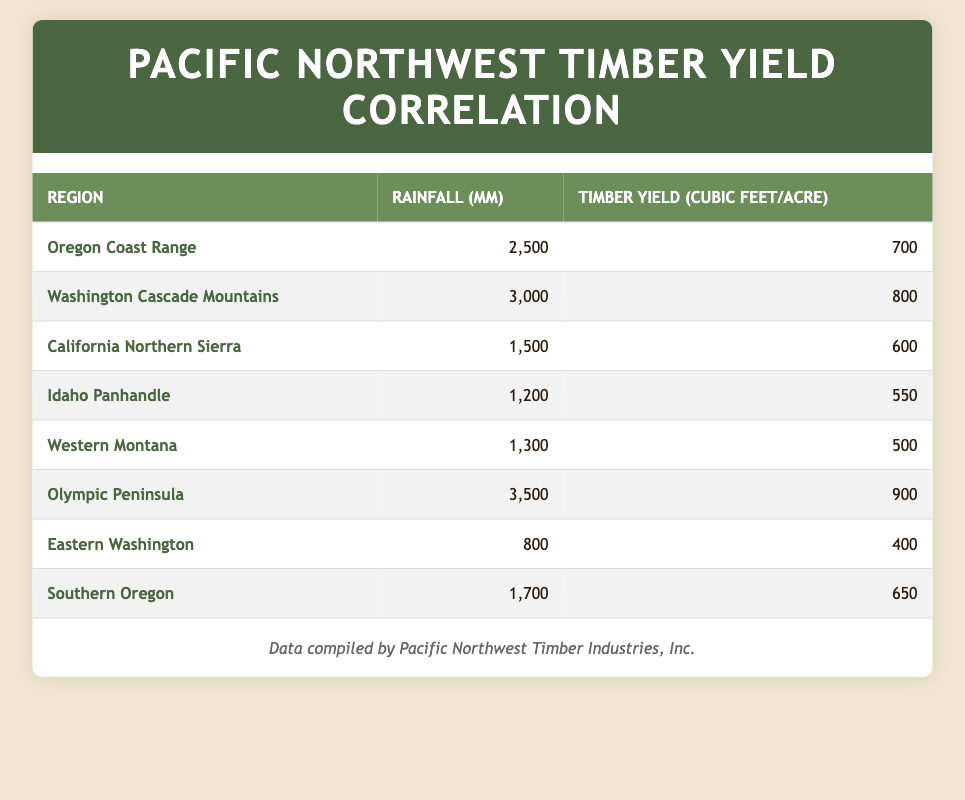What is the timber yield per acre for the Olympic Peninsula? The table shows the timber yield per acre for the Olympic Peninsula is listed directly under the "Timber Yield" column corresponding to that region, which is 900 cubic feet.
Answer: 900 What is the rainfall for the region with the highest timber yield per acre? By examining the timber yield values in the table, the Olympic Peninsula has the highest yield of 900 cubic feet per acre. The corresponding rainfall for that region is listed as 3500 mm.
Answer: 3500 mm Is the timber yield per acre greater than 700 cubic feet in the Washington Cascade Mountains? The table lists a timber yield of 800 cubic feet per acre for the Washington Cascade Mountains, which is indeed greater than 700 cubic feet.
Answer: Yes What is the total timber yield per acre for the Oregon Coast Range and Southern Oregon? The timber yield for the Oregon Coast Range is 700 cubic feet, and for Southern Oregon, it is 650 cubic feet. Summing these values gives a total of 700 + 650 = 1350 cubic feet per acre.
Answer: 1350 cubic feet Which region has more rainfall: Eastern Washington or Western Montana? The table shows that Eastern Washington has 800 mm of rainfall while Western Montana has 1300 mm. Since 1300 mm is greater than 800 mm, Western Montana has more rainfall.
Answer: Western Montana What is the average rainfall across all regions presented in the table? To calculate the average rainfall, first, sum the rainfall values: 2500 + 3000 + 1500 + 1200 + 1300 + 3500 + 800 + 1700 = 14500 mm. There are 8 regions, so the average rainfall is 14500 mm / 8 = 1812.5 mm.
Answer: 1812.5 mm Is it true that all regions with over 3000 mm of rainfall have a timber yield greater than 800 cubic feet per acre? The Olympic Peninsula has 3500 mm of rainfall and a yield of 900 cubic feet, which is greater than 800. However, the Washington Cascade Mountains has 3000 mm of rainfall and a yield of 800 cubic feet, which is not greater but equal to 800. Therefore, the statement is false.
Answer: No Which region has the lowest timber yield per acre? Examining the timber yield values, the region with the lowest timber yield per acre is Western Montana with 500 cubic feet listed in the table.
Answer: 500 cubic feet 